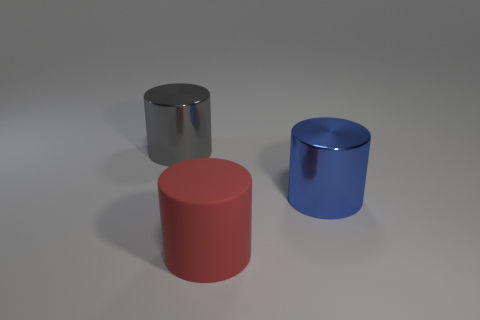Is there any other thing that is the same color as the large rubber cylinder?
Offer a terse response. No. Is the number of blue objects to the left of the big rubber object less than the number of red rubber objects?
Your answer should be very brief. Yes. Is the number of red rubber cylinders greater than the number of big shiny cylinders?
Make the answer very short. No. There is a metal thing that is to the right of the large cylinder that is behind the blue shiny thing; are there any blue cylinders in front of it?
Your response must be concise. No. What number of other objects are there of the same size as the blue metal cylinder?
Offer a very short reply. 2. There is a big rubber object; are there any big red cylinders behind it?
Make the answer very short. No. Is the color of the big rubber cylinder the same as the large thing behind the blue metal cylinder?
Your response must be concise. No. There is a shiny object to the left of the large metallic cylinder that is on the right side of the matte thing on the right side of the gray thing; what is its color?
Keep it short and to the point. Gray. Are there any other big matte things of the same shape as the red matte thing?
Your answer should be very brief. No. What color is the other rubber thing that is the same size as the blue object?
Give a very brief answer. Red. 